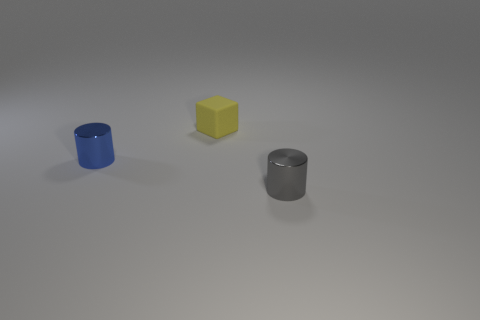Could you describe the possible materials of these objects? Certainly, the cylindrical container to the left appears to be made of a glossy, painted material, perhaps ceramic or plastic. The central yellow block has a matte texture that could suggest a sanded wood or a dense foam. The cylindrical shape on the right has a reflective surface, indicative of a metallic material, like aluminum or steel.  What could be the function of these objects in a real-world setting? The blue container could be a simplistic vase or a pen holder, the yellow block might serve as an abstract paperweight, and the metallic cylinder could be a stylish modernist mug or a small storage container. 